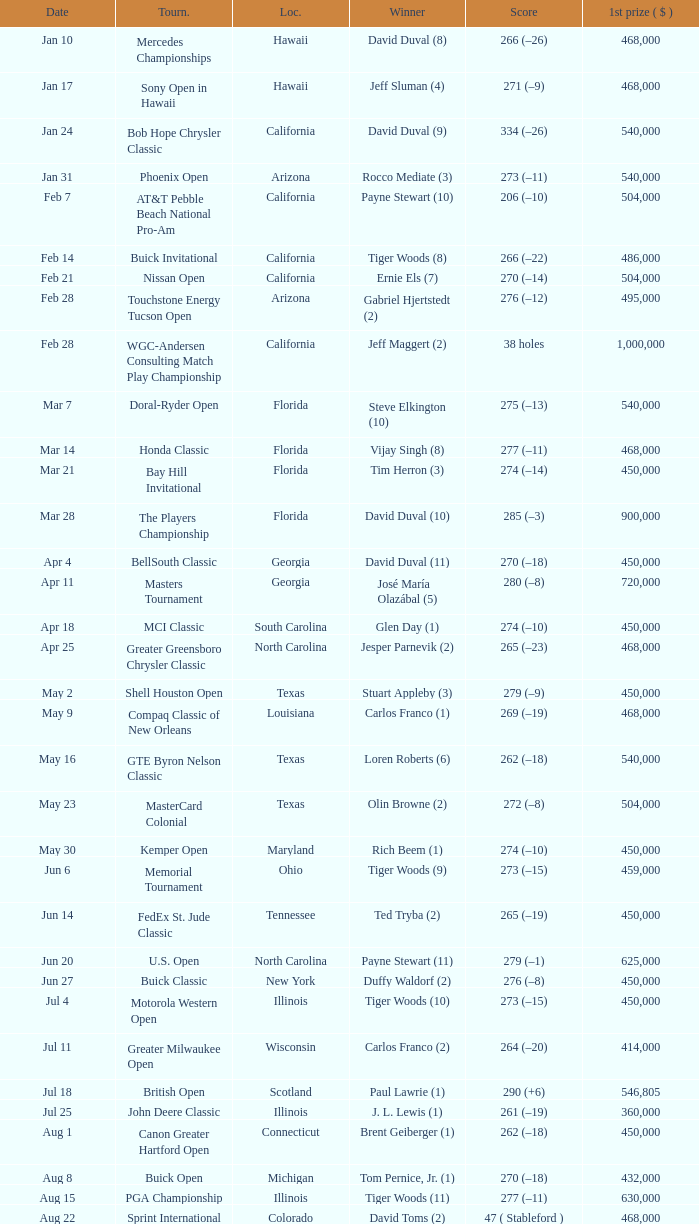Who is the winner of the tournament in Georgia on Oct 3? David Toms (3). 